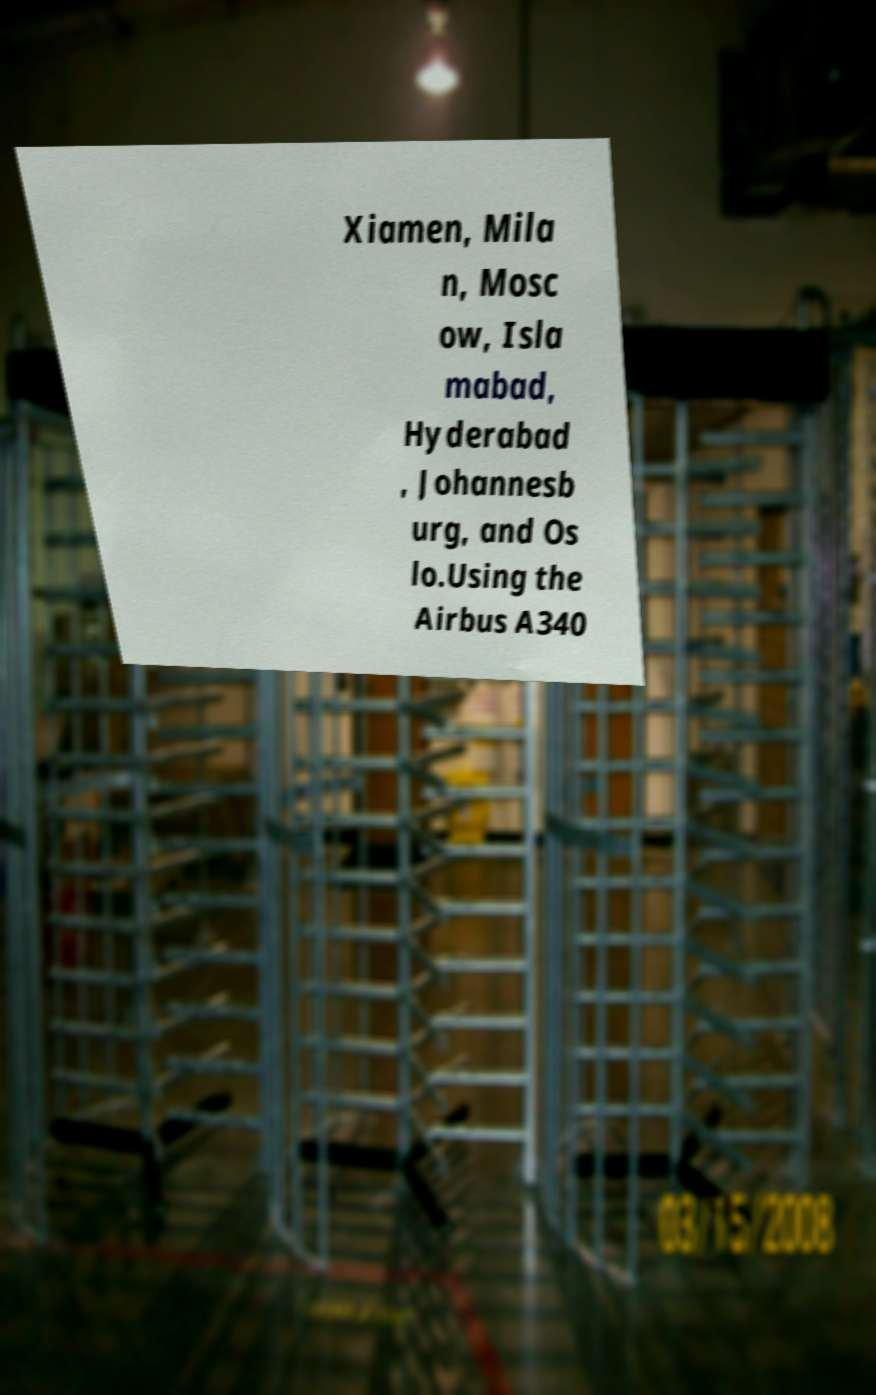There's text embedded in this image that I need extracted. Can you transcribe it verbatim? Xiamen, Mila n, Mosc ow, Isla mabad, Hyderabad , Johannesb urg, and Os lo.Using the Airbus A340 